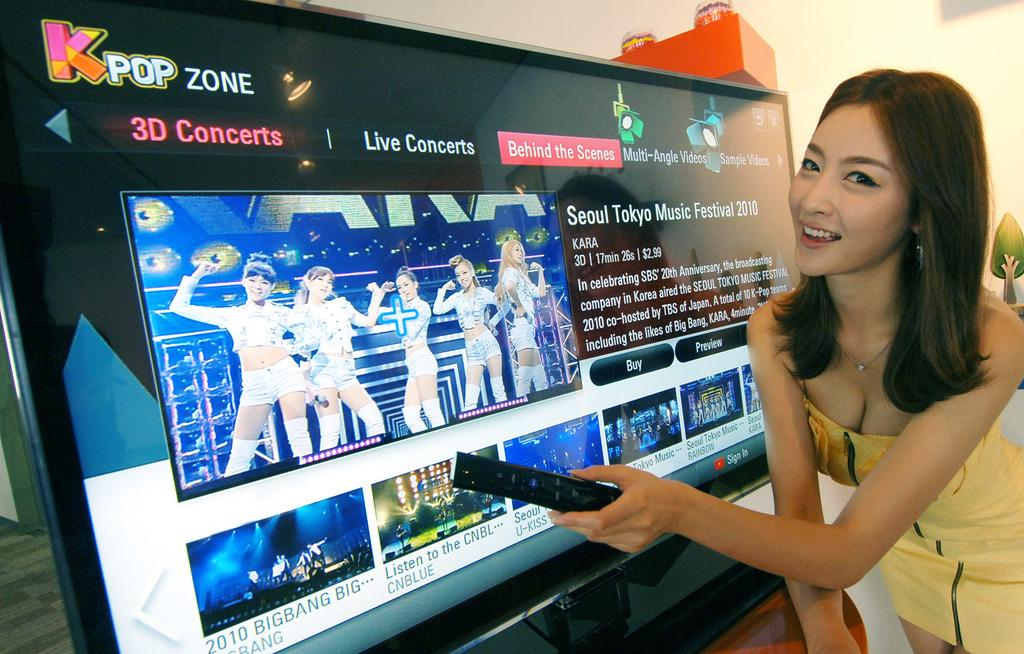<image>
Render a clear and concise summary of the photo. A woman in a yellow dress is posing in front of a television with Live conccerts being displayed on the top. 